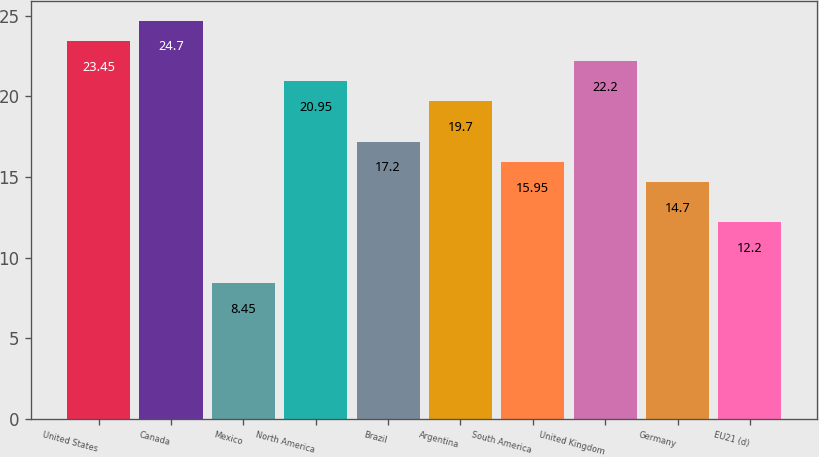<chart> <loc_0><loc_0><loc_500><loc_500><bar_chart><fcel>United States<fcel>Canada<fcel>Mexico<fcel>North America<fcel>Brazil<fcel>Argentina<fcel>South America<fcel>United Kingdom<fcel>Germany<fcel>EU21 (d)<nl><fcel>23.45<fcel>24.7<fcel>8.45<fcel>20.95<fcel>17.2<fcel>19.7<fcel>15.95<fcel>22.2<fcel>14.7<fcel>12.2<nl></chart> 